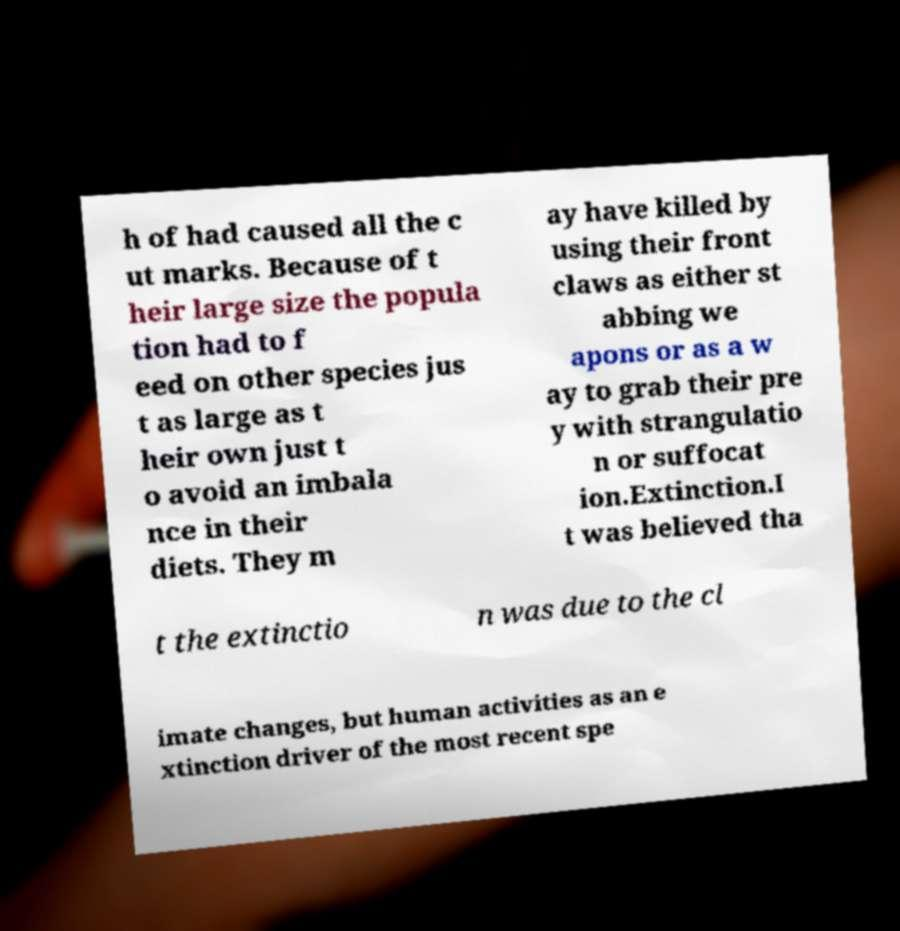Can you accurately transcribe the text from the provided image for me? h of had caused all the c ut marks. Because of t heir large size the popula tion had to f eed on other species jus t as large as t heir own just t o avoid an imbala nce in their diets. They m ay have killed by using their front claws as either st abbing we apons or as a w ay to grab their pre y with strangulatio n or suffocat ion.Extinction.I t was believed tha t the extinctio n was due to the cl imate changes, but human activities as an e xtinction driver of the most recent spe 